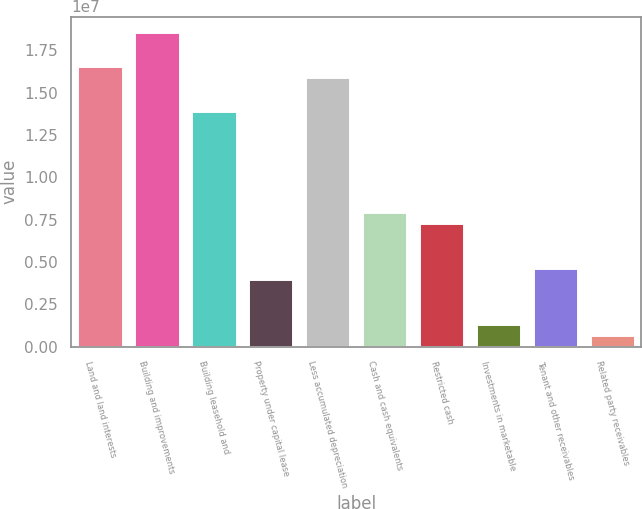<chart> <loc_0><loc_0><loc_500><loc_500><bar_chart><fcel>Land and land interests<fcel>Building and improvements<fcel>Building leasehold and<fcel>Property under capital lease<fcel>Less accumulated depreciation<fcel>Cash and cash equivalents<fcel>Restricted cash<fcel>Investments in marketable<fcel>Tenant and other receivables<fcel>Related party receivables<nl><fcel>1.65695e+07<fcel>1.85575e+07<fcel>1.39189e+07<fcel>3.97915e+06<fcel>1.59069e+07<fcel>7.95507e+06<fcel>7.29241e+06<fcel>1.32854e+06<fcel>4.6418e+06<fcel>665891<nl></chart> 